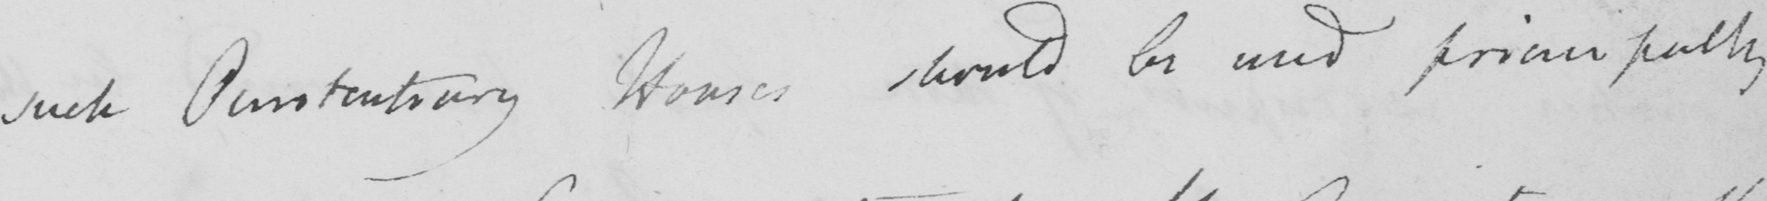Transcribe the text shown in this historical manuscript line. such Penitentiary Houses should be used principally 